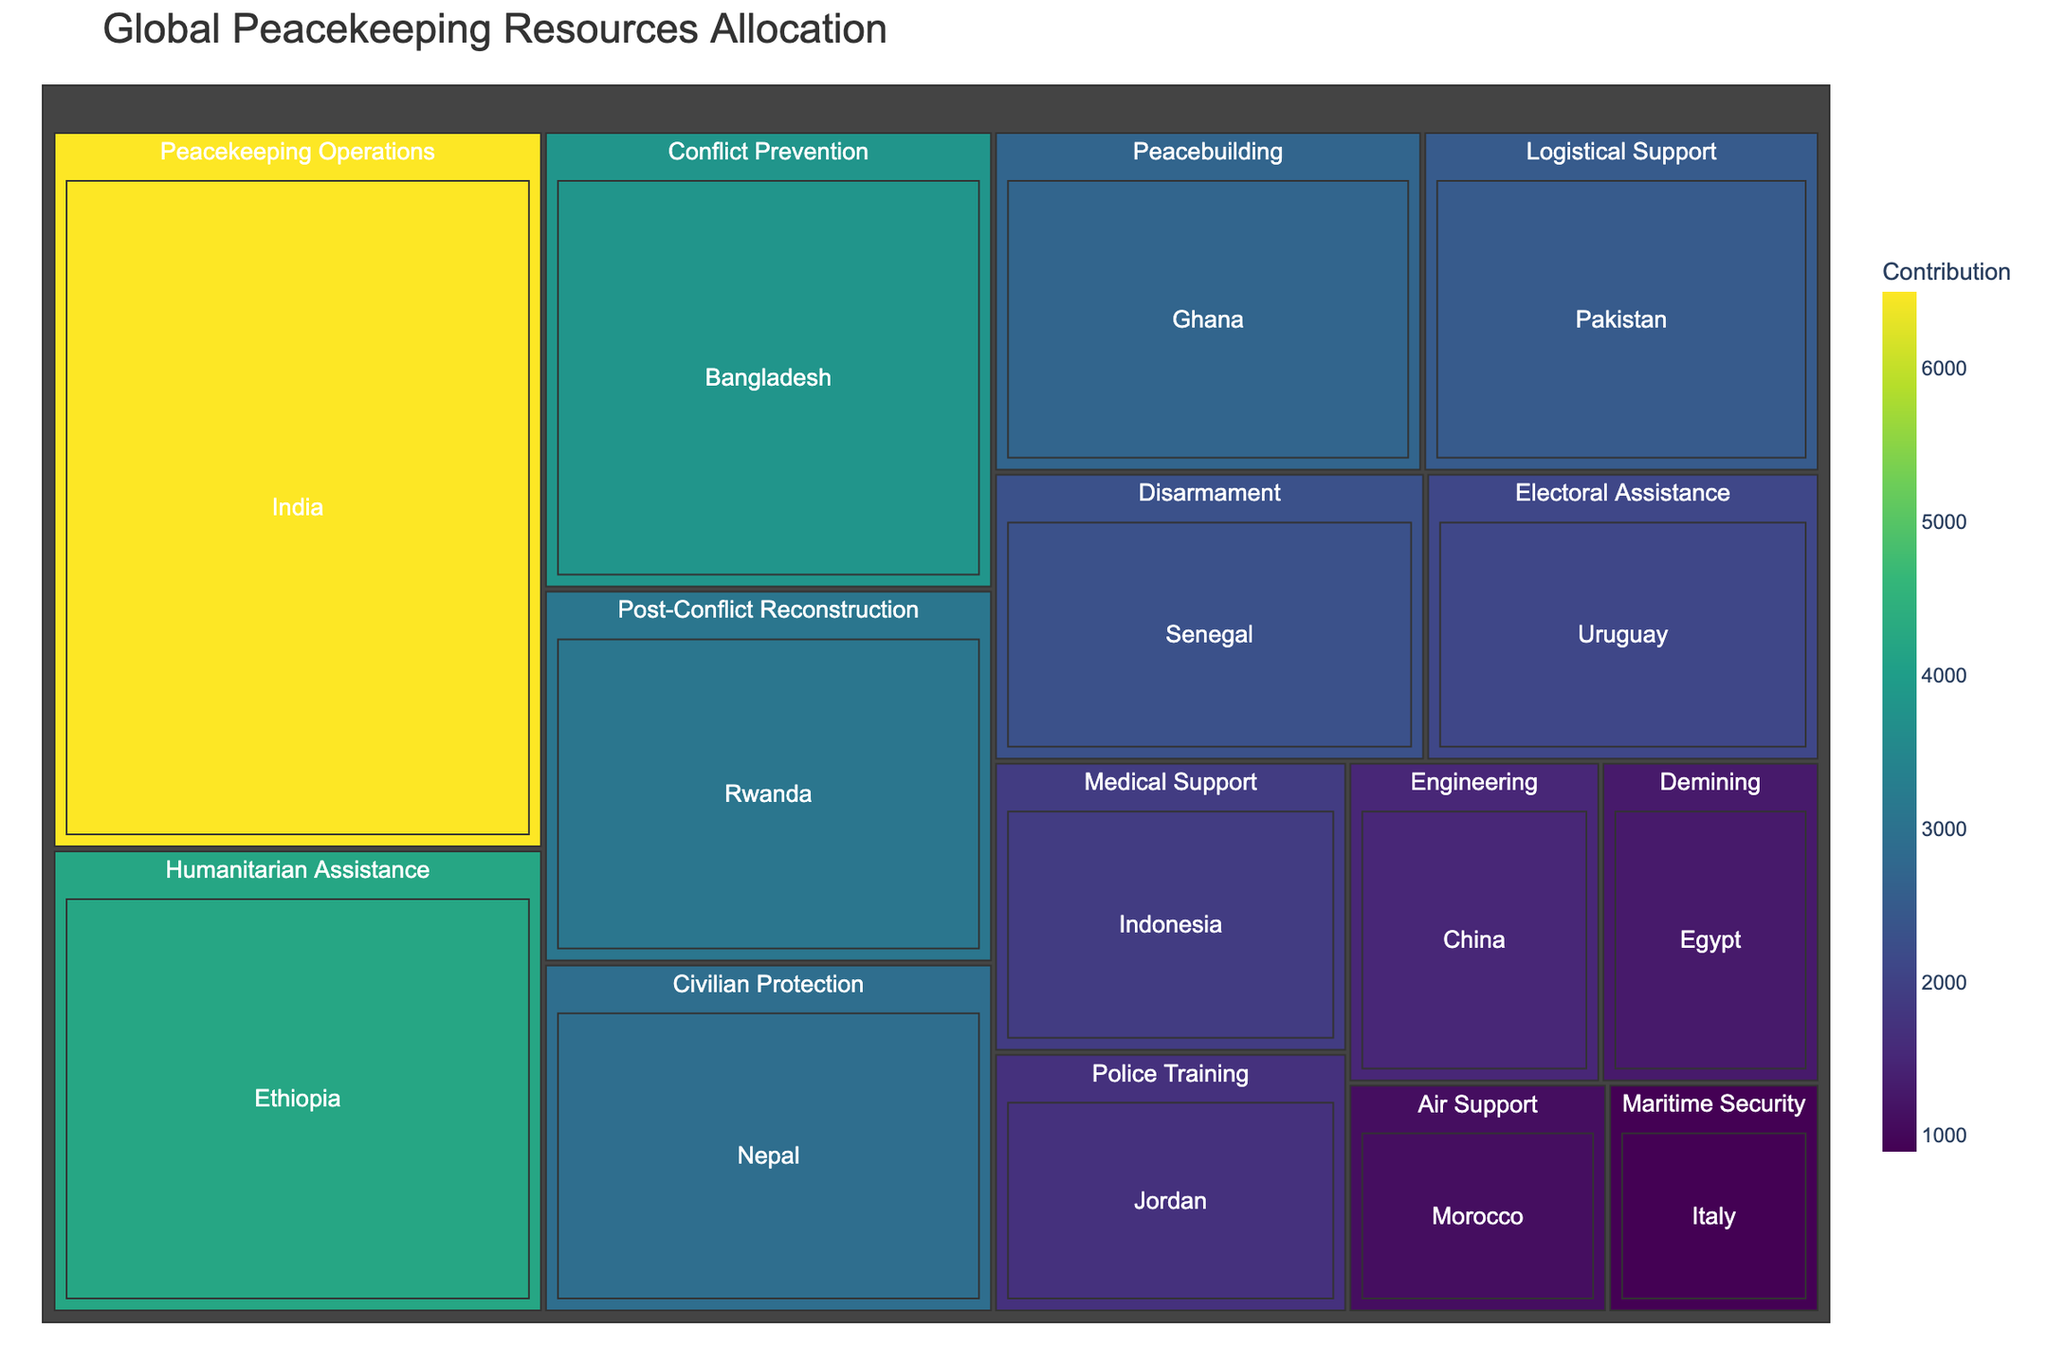Which country has the highest contribution to Peacekeeping Operations? By observing the segment labeled "Peacekeeping Operations" within the treemap, we see that India has the largest contribution value
Answer: India What's the smallest contribution and which mission type and country does it correspond to? The smallest contribution can be found by identifying the smallest rectangle and its label in the treemap. It's 900, corresponding to Maritime Security by Italy
Answer: 900, Maritime Security by Italy How many countries are contributing to Humanitarian Assistance? By locating the "Humanitarian Assistance" segment in the treemap and counting its inner rectangles, we find it corresponds to one country, Ethiopia
Answer: 1 Compare the total contribution of Civilian Protection and Peacebuilding missions. Which one is higher? Sum the contributions for Civilian Protection (2900) and for Peacebuilding (2700). Civilian Protection has a higher total contribution than Peacebuilding
Answer: Civilian Protection What's the difference in contributions between the largest and the second largest country contributions? The largest contribution is from India (6500) and the second largest is from Ethiopia (4200). The difference is calculated as 6500 - 4200
Answer: 2300 Identify the mission type that Indonesia contributes to. By finding Indonesia in the treemap, we see that it contributes to Medical Support
Answer: Medical Support What is the average contribution of countries involved in Disarmament and Demining missions? Sum the contributions for Disarmament (2300) and Demining (1300), then divide by the number of contributing countries (2), so (2300 + 1300) / 2 = 1800
Answer: 1800 Which country contributes to Police Training, and with how much? By locating the "Police Training" segment in the treemap, we find Jordan contributes 1700
Answer: Jordan, 1700 How many different mission types are depicted in the treemap? Count the distinct mission type segments in the treemap. There are 15 different mission types
Answer: 15 What's the combined contribution of countries contributing to engineering-related missions? Only China contributes to Engineering with a value of 1500
Answer: 1500 